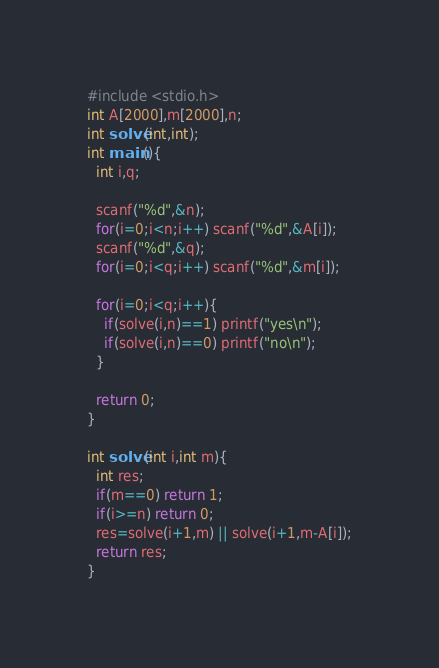<code> <loc_0><loc_0><loc_500><loc_500><_C_>#include <stdio.h>
int A[2000],m[2000],n;
int solve(int,int);
int main(){
  int i,q;

  scanf("%d",&n);
  for(i=0;i<n;i++) scanf("%d",&A[i]);
  scanf("%d",&q);
  for(i=0;i<q;i++) scanf("%d",&m[i]);

  for(i=0;i<q;i++){
    if(solve(i,n)==1) printf("yes\n");
    if(solve(i,n)==0) printf("no\n");
  }
  
  return 0;
}

int solve(int i,int m){
  int res;
  if(m==0) return 1;
  if(i>=n) return 0;
  res=solve(i+1,m) || solve(i+1,m-A[i]);
  return res;
}

</code> 